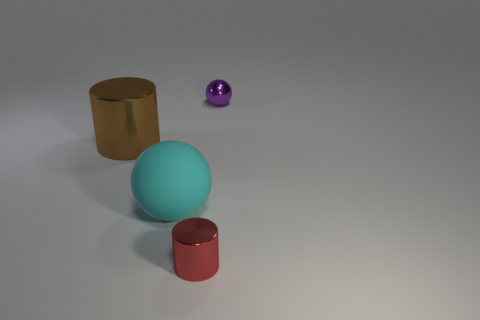Is the rubber thing the same size as the purple object?
Offer a terse response. No. Is the number of balls greater than the number of brown shiny cubes?
Offer a terse response. Yes. What number of other things are the same color as the large metallic cylinder?
Offer a very short reply. 0. How many things are purple metallic balls or brown cylinders?
Provide a short and direct response. 2. There is a metallic thing that is to the left of the red object; does it have the same shape as the red object?
Provide a short and direct response. Yes. What is the color of the metal object right of the tiny object that is in front of the brown shiny cylinder?
Your response must be concise. Purple. Is the number of tiny purple objects less than the number of small cyan spheres?
Provide a succinct answer. No. Are there any tiny red objects made of the same material as the small purple sphere?
Provide a succinct answer. Yes. There is a purple metal thing; is its shape the same as the small metal thing that is in front of the large brown thing?
Give a very brief answer. No. Are there any tiny red metal things in front of the big brown metal object?
Offer a terse response. Yes. 